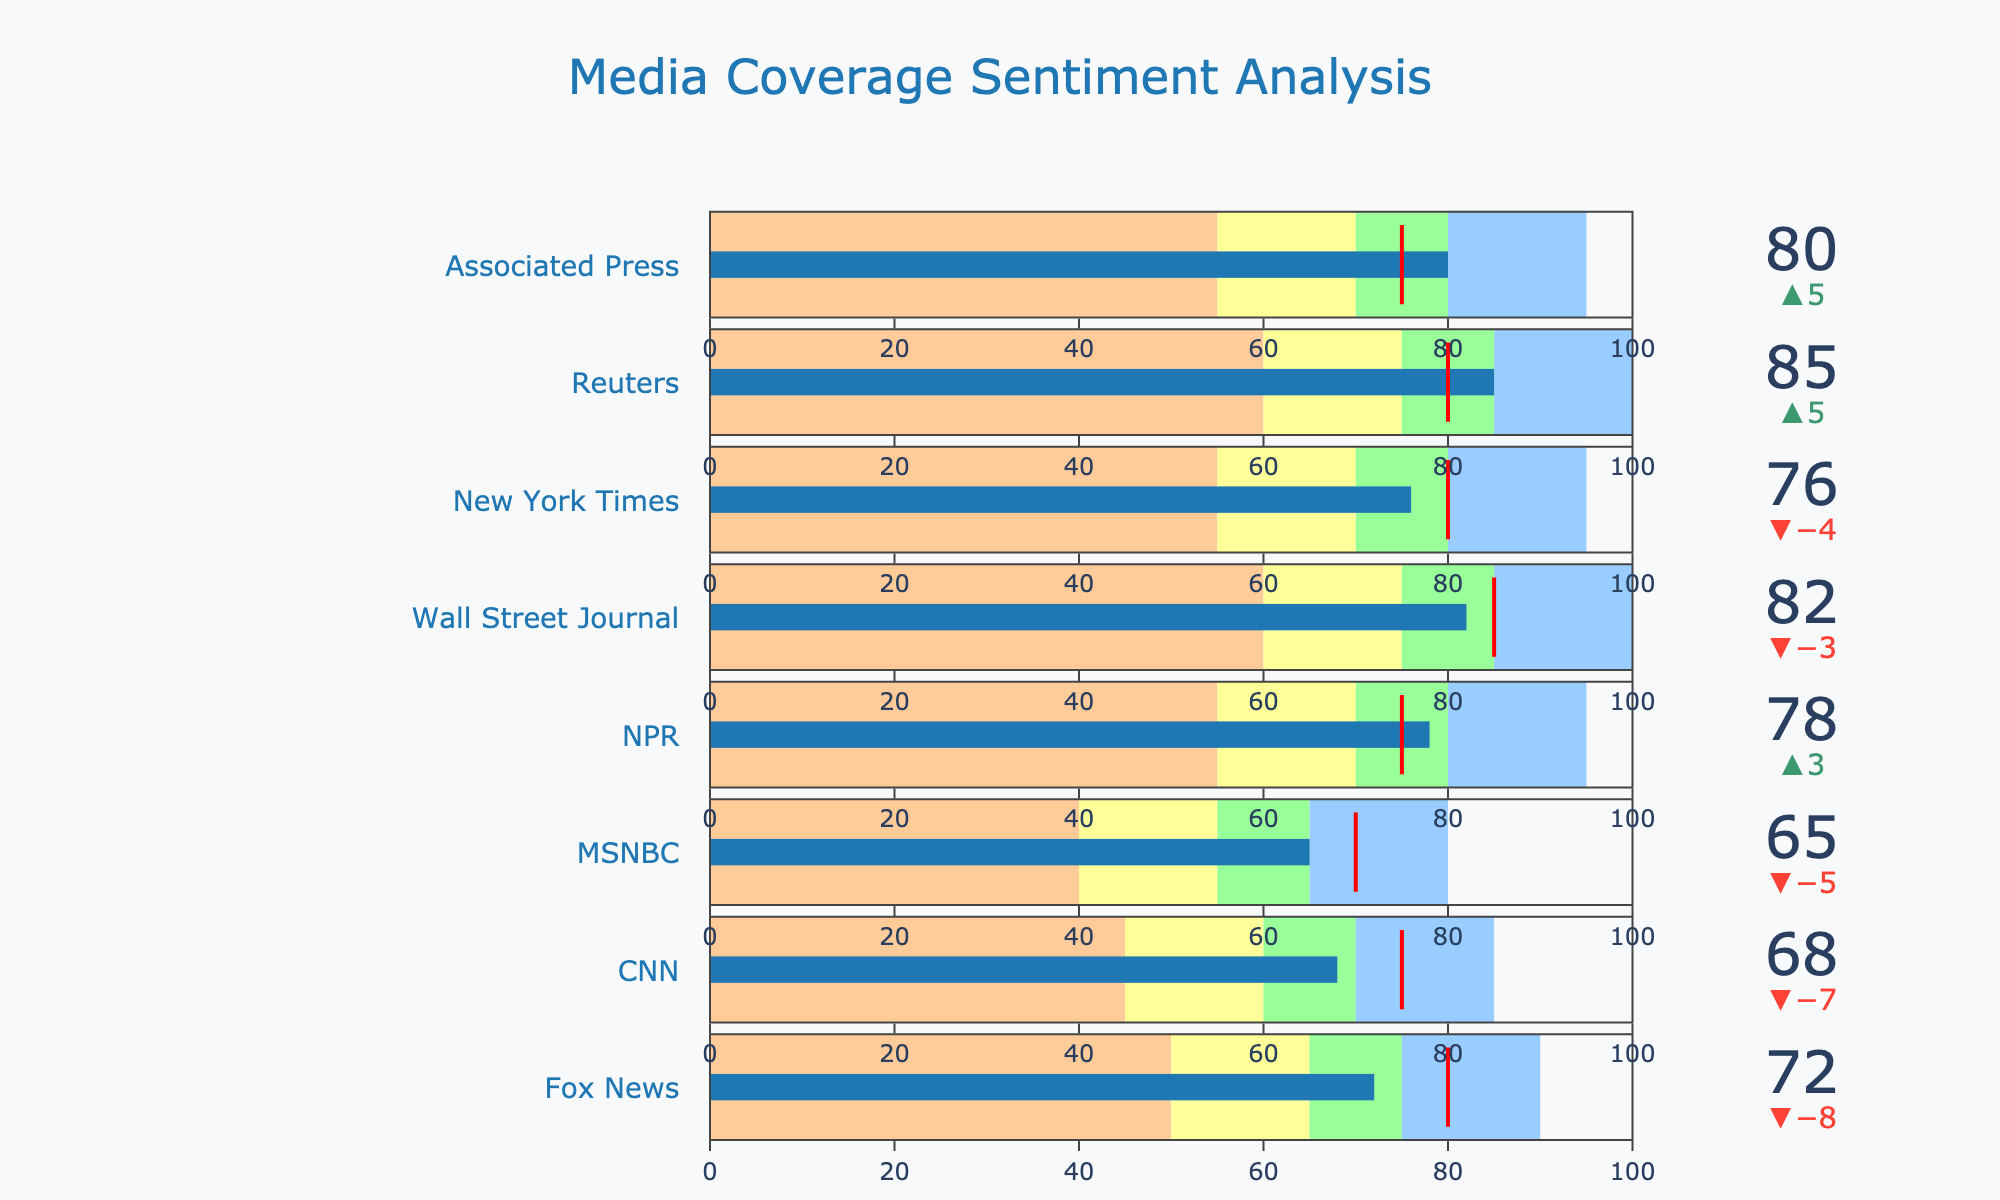What is the maximum value range for the gauge on the bullet chart? The maximum value range for the gauge is indicated by the highest number in the "Excellent" category. By reviewing the data, the highest "Excellent" value is 100.
Answer: 100 Which media outlet has the highest actual sentiment value? To identify the media outlet with the highest actual sentiment value, we need to compare the "Actual" values for each outlet. "Reuters" has the highest value of 85.
Answer: Reuters How many media outlets meet or exceed their target sentiment value? We need to count the number of outlets where the "Actual" value is equal to or greater than the "Target" value. Reuters (85/80), NPR (78/75), Associated Press (80/75), New York Times (76/75).  So, there are 4 in total.
Answer: 4 Which media outlets fall into the "Very Good" range based on their actual sentiment values? To determine this, we need to check which outlets have actual sentiment values falling between "Very Good" and "Excellent" ranges. Associated Press (80/95).
Answer: Associated Press How much does Fox News fall short of its target sentiment value? To find out how much Fox News falls short, we subtract the actual value from the target value (80 - 72 = 8).
Answer: 8 Which outlet's actual sentiment value is closest to its target sentiment value? Calculate the absolute difference between actual and target values for each outlet and compare. Fox News (80-72=8), CNN (75-68=7), MSNBC (70-65=5), NPR (75-78=3), WSJ (85-82=3), NYT (80-76=4), Reuters (80-85=5), AP (75-80=5). NPR and WSJ both have a difference of 3, the smallest difference.
Answer: NPR and WSJ What is the average actual sentiment value among all the media outlets? Sum up all actual sentiment values and then divide by the number of outlets: (72+68+65+78+82+76+85+80)/8 = 606/8 = 75.75
Answer: 75.75 What color represents the "Poor" range in the bullet chart? The color for the "Poor" range is displayed as "#ff9999", which translates to a shade of red.
Answer: Red Of the media outlets that exceeded their target, which one has the largest difference between actual and target sentiment values? Compare the differences where actual values exceed target values. Reuters (85-80=5), AP (80-75=5), NPR (78-75=3), NYT (76-75=1). Reuters and AP both have the largest difference of 5.
Answer: Reuters and AP Which media outlet has the actual sentiment value that falls into the "Good" range? We need to check which "Actual" values fall between the "Good" and "Very Good" intervals. Specifically, Fox News (72 falls in 65-75), CNN (68 falls in 60-70).
Answer: Fox News, CNN 